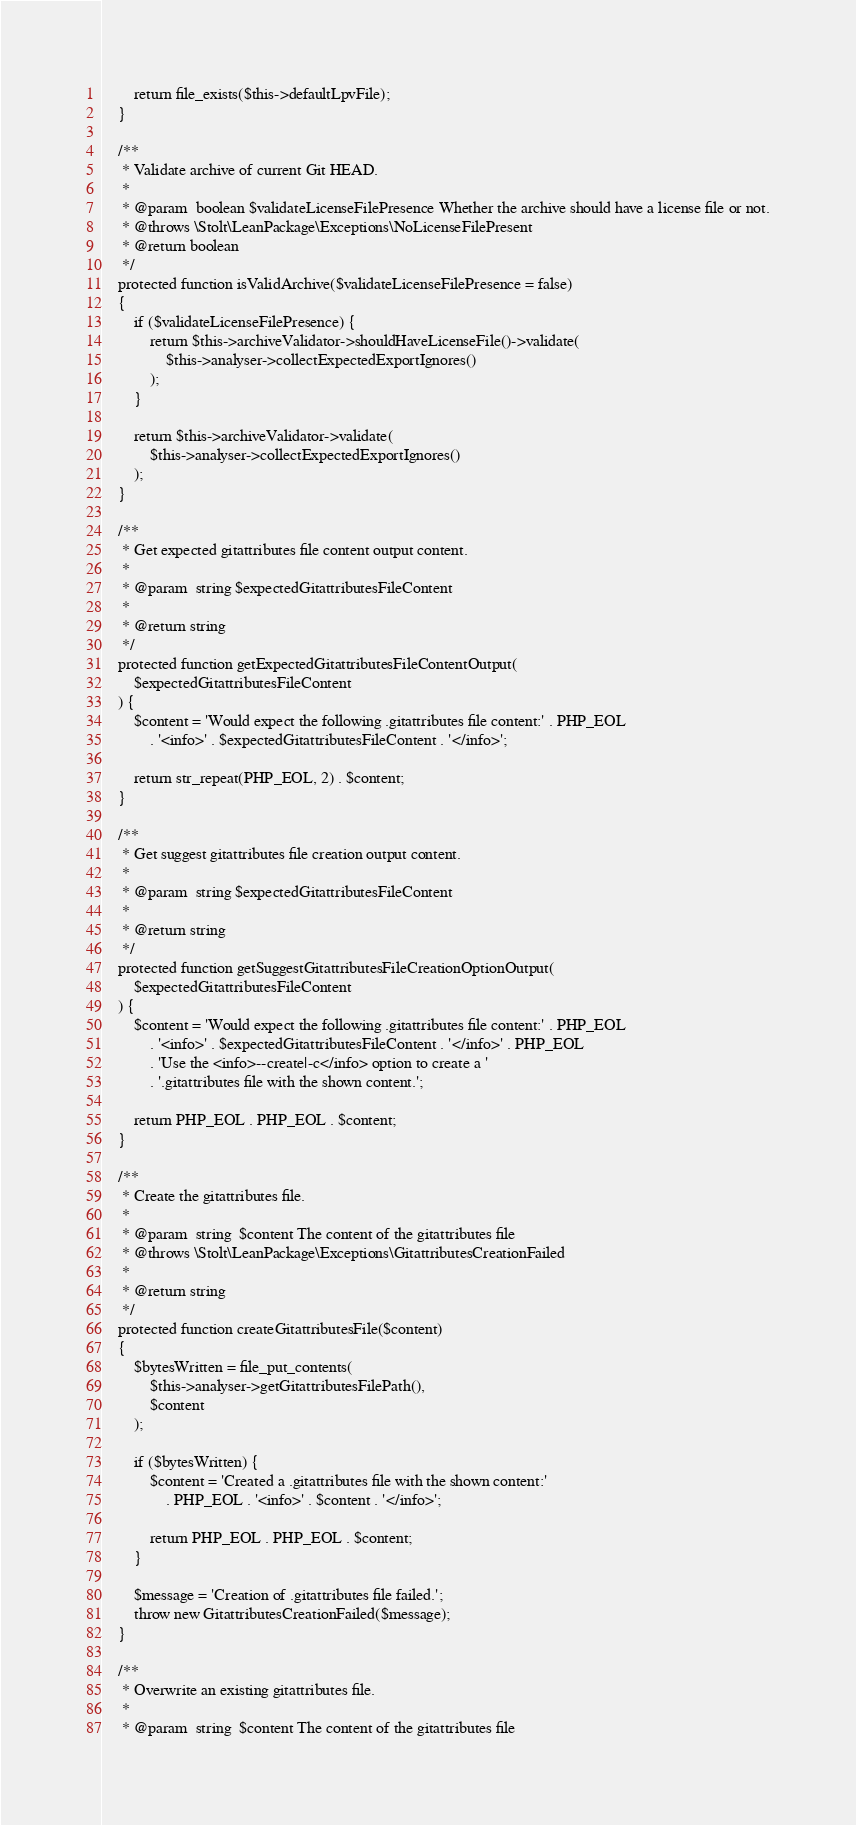<code> <loc_0><loc_0><loc_500><loc_500><_PHP_>        return file_exists($this->defaultLpvFile);
    }

    /**
     * Validate archive of current Git HEAD.
     *
     * @param  boolean $validateLicenseFilePresence Whether the archive should have a license file or not.
     * @throws \Stolt\LeanPackage\Exceptions\NoLicenseFilePresent
     * @return boolean
     */
    protected function isValidArchive($validateLicenseFilePresence = false)
    {
        if ($validateLicenseFilePresence) {
            return $this->archiveValidator->shouldHaveLicenseFile()->validate(
                $this->analyser->collectExpectedExportIgnores()
            );
        }

        return $this->archiveValidator->validate(
            $this->analyser->collectExpectedExportIgnores()
        );
    }

    /**
     * Get expected gitattributes file content output content.
     *
     * @param  string $expectedGitattributesFileContent
     *
     * @return string
     */
    protected function getExpectedGitattributesFileContentOutput(
        $expectedGitattributesFileContent
    ) {
        $content = 'Would expect the following .gitattributes file content:' . PHP_EOL
            . '<info>' . $expectedGitattributesFileContent . '</info>';

        return str_repeat(PHP_EOL, 2) . $content;
    }

    /**
     * Get suggest gitattributes file creation output content.
     *
     * @param  string $expectedGitattributesFileContent
     *
     * @return string
     */
    protected function getSuggestGitattributesFileCreationOptionOutput(
        $expectedGitattributesFileContent
    ) {
        $content = 'Would expect the following .gitattributes file content:' . PHP_EOL
            . '<info>' . $expectedGitattributesFileContent . '</info>' . PHP_EOL
            . 'Use the <info>--create|-c</info> option to create a '
            . '.gitattributes file with the shown content.';

        return PHP_EOL . PHP_EOL . $content;
    }

    /**
     * Create the gitattributes file.
     *
     * @param  string  $content The content of the gitattributes file
     * @throws \Stolt\LeanPackage\Exceptions\GitattributesCreationFailed
     *
     * @return string
     */
    protected function createGitattributesFile($content)
    {
        $bytesWritten = file_put_contents(
            $this->analyser->getGitattributesFilePath(),
            $content
        );

        if ($bytesWritten) {
            $content = 'Created a .gitattributes file with the shown content:'
                . PHP_EOL . '<info>' . $content . '</info>';

            return PHP_EOL . PHP_EOL . $content;
        }

        $message = 'Creation of .gitattributes file failed.';
        throw new GitattributesCreationFailed($message);
    }

    /**
     * Overwrite an existing gitattributes file.
     *
     * @param  string  $content The content of the gitattributes file</code> 